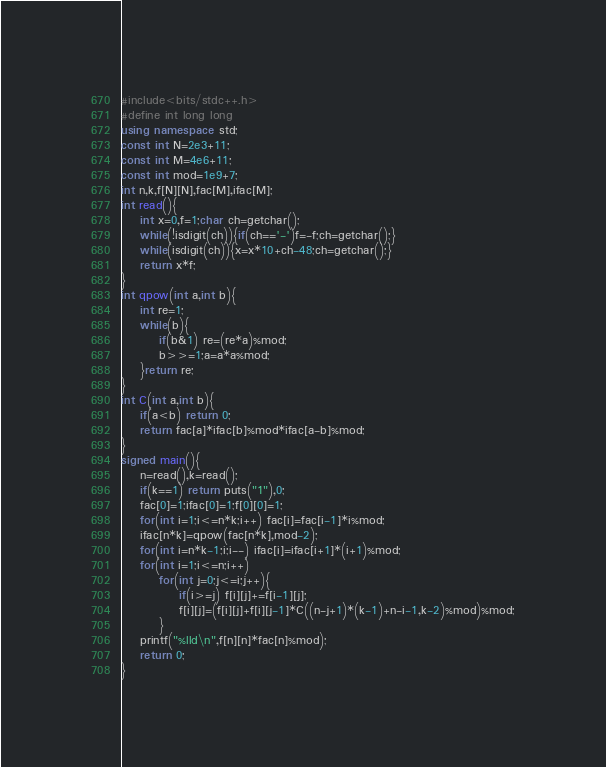Convert code to text. <code><loc_0><loc_0><loc_500><loc_500><_C++_>#include<bits/stdc++.h>
#define int long long
using namespace std;
const int N=2e3+11;
const int M=4e6+11;
const int mod=1e9+7;
int n,k,f[N][N],fac[M],ifac[M];
int read(){
    int x=0,f=1;char ch=getchar();
    while(!isdigit(ch)){if(ch=='-')f=-f;ch=getchar();}
    while(isdigit(ch)){x=x*10+ch-48;ch=getchar();}
    return x*f;
}
int qpow(int a,int b){
    int re=1;
    while(b){
        if(b&1) re=(re*a)%mod;
        b>>=1;a=a*a%mod;
    }return re;
}
int C(int a,int b){
    if(a<b) return 0;
    return fac[a]*ifac[b]%mod*ifac[a-b]%mod;
}
signed main(){
    n=read(),k=read();
    if(k==1) return puts("1"),0;
    fac[0]=1;ifac[0]=1;f[0][0]=1;
    for(int i=1;i<=n*k;i++) fac[i]=fac[i-1]*i%mod;
    ifac[n*k]=qpow(fac[n*k],mod-2);
    for(int i=n*k-1;i;i--) ifac[i]=ifac[i+1]*(i+1)%mod;
    for(int i=1;i<=n;i++)
        for(int j=0;j<=i;j++){
            if(i>=j) f[i][j]+=f[i-1][j];
            f[i][j]=(f[i][j]+f[i][j-1]*C((n-j+1)*(k-1)+n-i-1,k-2)%mod)%mod;
        }
    printf("%lld\n",f[n][n]*fac[n]%mod);
    return 0;
}</code> 